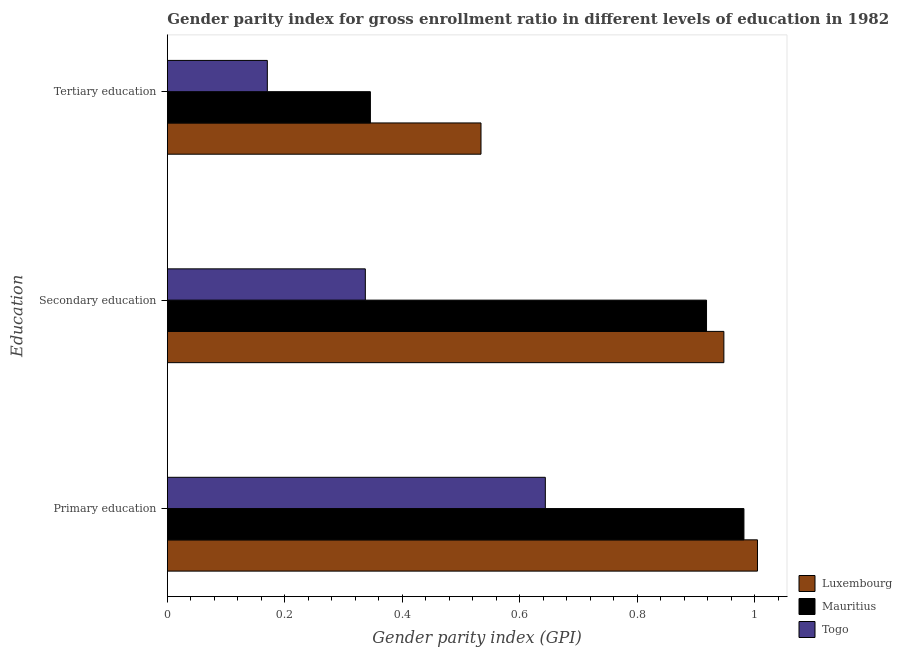How many different coloured bars are there?
Keep it short and to the point. 3. How many groups of bars are there?
Offer a very short reply. 3. What is the label of the 2nd group of bars from the top?
Offer a very short reply. Secondary education. What is the gender parity index in secondary education in Luxembourg?
Your answer should be compact. 0.95. Across all countries, what is the maximum gender parity index in secondary education?
Keep it short and to the point. 0.95. Across all countries, what is the minimum gender parity index in secondary education?
Your response must be concise. 0.34. In which country was the gender parity index in tertiary education maximum?
Give a very brief answer. Luxembourg. In which country was the gender parity index in primary education minimum?
Keep it short and to the point. Togo. What is the total gender parity index in tertiary education in the graph?
Your answer should be compact. 1.05. What is the difference between the gender parity index in secondary education in Mauritius and that in Togo?
Provide a succinct answer. 0.58. What is the difference between the gender parity index in tertiary education in Luxembourg and the gender parity index in primary education in Mauritius?
Offer a terse response. -0.45. What is the average gender parity index in primary education per country?
Ensure brevity in your answer.  0.88. What is the difference between the gender parity index in tertiary education and gender parity index in secondary education in Togo?
Give a very brief answer. -0.17. What is the ratio of the gender parity index in primary education in Mauritius to that in Togo?
Keep it short and to the point. 1.53. Is the difference between the gender parity index in tertiary education in Luxembourg and Mauritius greater than the difference between the gender parity index in primary education in Luxembourg and Mauritius?
Keep it short and to the point. Yes. What is the difference between the highest and the second highest gender parity index in secondary education?
Provide a short and direct response. 0.03. What is the difference between the highest and the lowest gender parity index in secondary education?
Your answer should be compact. 0.61. In how many countries, is the gender parity index in primary education greater than the average gender parity index in primary education taken over all countries?
Provide a succinct answer. 2. What does the 2nd bar from the top in Secondary education represents?
Keep it short and to the point. Mauritius. What does the 1st bar from the bottom in Primary education represents?
Provide a short and direct response. Luxembourg. How many bars are there?
Provide a short and direct response. 9. Are all the bars in the graph horizontal?
Provide a short and direct response. Yes. Are the values on the major ticks of X-axis written in scientific E-notation?
Provide a succinct answer. No. Where does the legend appear in the graph?
Your answer should be very brief. Bottom right. What is the title of the graph?
Offer a very short reply. Gender parity index for gross enrollment ratio in different levels of education in 1982. Does "Angola" appear as one of the legend labels in the graph?
Offer a terse response. No. What is the label or title of the X-axis?
Your answer should be compact. Gender parity index (GPI). What is the label or title of the Y-axis?
Your response must be concise. Education. What is the Gender parity index (GPI) in Luxembourg in Primary education?
Make the answer very short. 1. What is the Gender parity index (GPI) in Mauritius in Primary education?
Your answer should be compact. 0.98. What is the Gender parity index (GPI) of Togo in Primary education?
Your response must be concise. 0.64. What is the Gender parity index (GPI) of Luxembourg in Secondary education?
Give a very brief answer. 0.95. What is the Gender parity index (GPI) of Mauritius in Secondary education?
Make the answer very short. 0.92. What is the Gender parity index (GPI) in Togo in Secondary education?
Ensure brevity in your answer.  0.34. What is the Gender parity index (GPI) in Luxembourg in Tertiary education?
Offer a very short reply. 0.53. What is the Gender parity index (GPI) of Mauritius in Tertiary education?
Offer a terse response. 0.35. What is the Gender parity index (GPI) of Togo in Tertiary education?
Ensure brevity in your answer.  0.17. Across all Education, what is the maximum Gender parity index (GPI) of Luxembourg?
Keep it short and to the point. 1. Across all Education, what is the maximum Gender parity index (GPI) of Mauritius?
Your response must be concise. 0.98. Across all Education, what is the maximum Gender parity index (GPI) in Togo?
Your response must be concise. 0.64. Across all Education, what is the minimum Gender parity index (GPI) in Luxembourg?
Give a very brief answer. 0.53. Across all Education, what is the minimum Gender parity index (GPI) in Mauritius?
Keep it short and to the point. 0.35. Across all Education, what is the minimum Gender parity index (GPI) of Togo?
Offer a very short reply. 0.17. What is the total Gender parity index (GPI) in Luxembourg in the graph?
Give a very brief answer. 2.49. What is the total Gender parity index (GPI) of Mauritius in the graph?
Ensure brevity in your answer.  2.25. What is the total Gender parity index (GPI) in Togo in the graph?
Give a very brief answer. 1.15. What is the difference between the Gender parity index (GPI) in Luxembourg in Primary education and that in Secondary education?
Make the answer very short. 0.06. What is the difference between the Gender parity index (GPI) in Mauritius in Primary education and that in Secondary education?
Your answer should be compact. 0.06. What is the difference between the Gender parity index (GPI) in Togo in Primary education and that in Secondary education?
Make the answer very short. 0.31. What is the difference between the Gender parity index (GPI) in Luxembourg in Primary education and that in Tertiary education?
Your answer should be very brief. 0.47. What is the difference between the Gender parity index (GPI) of Mauritius in Primary education and that in Tertiary education?
Offer a very short reply. 0.64. What is the difference between the Gender parity index (GPI) of Togo in Primary education and that in Tertiary education?
Make the answer very short. 0.47. What is the difference between the Gender parity index (GPI) in Luxembourg in Secondary education and that in Tertiary education?
Ensure brevity in your answer.  0.41. What is the difference between the Gender parity index (GPI) of Mauritius in Secondary education and that in Tertiary education?
Keep it short and to the point. 0.57. What is the difference between the Gender parity index (GPI) of Togo in Secondary education and that in Tertiary education?
Your answer should be compact. 0.17. What is the difference between the Gender parity index (GPI) of Luxembourg in Primary education and the Gender parity index (GPI) of Mauritius in Secondary education?
Ensure brevity in your answer.  0.09. What is the difference between the Gender parity index (GPI) in Luxembourg in Primary education and the Gender parity index (GPI) in Togo in Secondary education?
Your response must be concise. 0.67. What is the difference between the Gender parity index (GPI) in Mauritius in Primary education and the Gender parity index (GPI) in Togo in Secondary education?
Your response must be concise. 0.64. What is the difference between the Gender parity index (GPI) of Luxembourg in Primary education and the Gender parity index (GPI) of Mauritius in Tertiary education?
Make the answer very short. 0.66. What is the difference between the Gender parity index (GPI) of Luxembourg in Primary education and the Gender parity index (GPI) of Togo in Tertiary education?
Your response must be concise. 0.83. What is the difference between the Gender parity index (GPI) of Mauritius in Primary education and the Gender parity index (GPI) of Togo in Tertiary education?
Provide a short and direct response. 0.81. What is the difference between the Gender parity index (GPI) in Luxembourg in Secondary education and the Gender parity index (GPI) in Mauritius in Tertiary education?
Make the answer very short. 0.6. What is the difference between the Gender parity index (GPI) of Luxembourg in Secondary education and the Gender parity index (GPI) of Togo in Tertiary education?
Offer a very short reply. 0.78. What is the difference between the Gender parity index (GPI) in Mauritius in Secondary education and the Gender parity index (GPI) in Togo in Tertiary education?
Provide a succinct answer. 0.75. What is the average Gender parity index (GPI) of Luxembourg per Education?
Your answer should be very brief. 0.83. What is the average Gender parity index (GPI) in Mauritius per Education?
Offer a very short reply. 0.75. What is the average Gender parity index (GPI) of Togo per Education?
Your answer should be very brief. 0.38. What is the difference between the Gender parity index (GPI) of Luxembourg and Gender parity index (GPI) of Mauritius in Primary education?
Your response must be concise. 0.02. What is the difference between the Gender parity index (GPI) in Luxembourg and Gender parity index (GPI) in Togo in Primary education?
Your answer should be very brief. 0.36. What is the difference between the Gender parity index (GPI) of Mauritius and Gender parity index (GPI) of Togo in Primary education?
Provide a short and direct response. 0.34. What is the difference between the Gender parity index (GPI) of Luxembourg and Gender parity index (GPI) of Mauritius in Secondary education?
Keep it short and to the point. 0.03. What is the difference between the Gender parity index (GPI) in Luxembourg and Gender parity index (GPI) in Togo in Secondary education?
Offer a very short reply. 0.61. What is the difference between the Gender parity index (GPI) in Mauritius and Gender parity index (GPI) in Togo in Secondary education?
Give a very brief answer. 0.58. What is the difference between the Gender parity index (GPI) of Luxembourg and Gender parity index (GPI) of Mauritius in Tertiary education?
Your response must be concise. 0.19. What is the difference between the Gender parity index (GPI) of Luxembourg and Gender parity index (GPI) of Togo in Tertiary education?
Offer a very short reply. 0.36. What is the difference between the Gender parity index (GPI) of Mauritius and Gender parity index (GPI) of Togo in Tertiary education?
Offer a terse response. 0.18. What is the ratio of the Gender parity index (GPI) of Luxembourg in Primary education to that in Secondary education?
Provide a succinct answer. 1.06. What is the ratio of the Gender parity index (GPI) of Mauritius in Primary education to that in Secondary education?
Ensure brevity in your answer.  1.07. What is the ratio of the Gender parity index (GPI) of Togo in Primary education to that in Secondary education?
Your answer should be compact. 1.91. What is the ratio of the Gender parity index (GPI) in Luxembourg in Primary education to that in Tertiary education?
Offer a terse response. 1.88. What is the ratio of the Gender parity index (GPI) in Mauritius in Primary education to that in Tertiary education?
Keep it short and to the point. 2.84. What is the ratio of the Gender parity index (GPI) of Togo in Primary education to that in Tertiary education?
Provide a short and direct response. 3.78. What is the ratio of the Gender parity index (GPI) in Luxembourg in Secondary education to that in Tertiary education?
Ensure brevity in your answer.  1.77. What is the ratio of the Gender parity index (GPI) of Mauritius in Secondary education to that in Tertiary education?
Your answer should be compact. 2.66. What is the ratio of the Gender parity index (GPI) in Togo in Secondary education to that in Tertiary education?
Provide a succinct answer. 1.98. What is the difference between the highest and the second highest Gender parity index (GPI) of Luxembourg?
Provide a succinct answer. 0.06. What is the difference between the highest and the second highest Gender parity index (GPI) in Mauritius?
Give a very brief answer. 0.06. What is the difference between the highest and the second highest Gender parity index (GPI) in Togo?
Provide a short and direct response. 0.31. What is the difference between the highest and the lowest Gender parity index (GPI) in Luxembourg?
Your answer should be very brief. 0.47. What is the difference between the highest and the lowest Gender parity index (GPI) in Mauritius?
Offer a very short reply. 0.64. What is the difference between the highest and the lowest Gender parity index (GPI) of Togo?
Your answer should be compact. 0.47. 